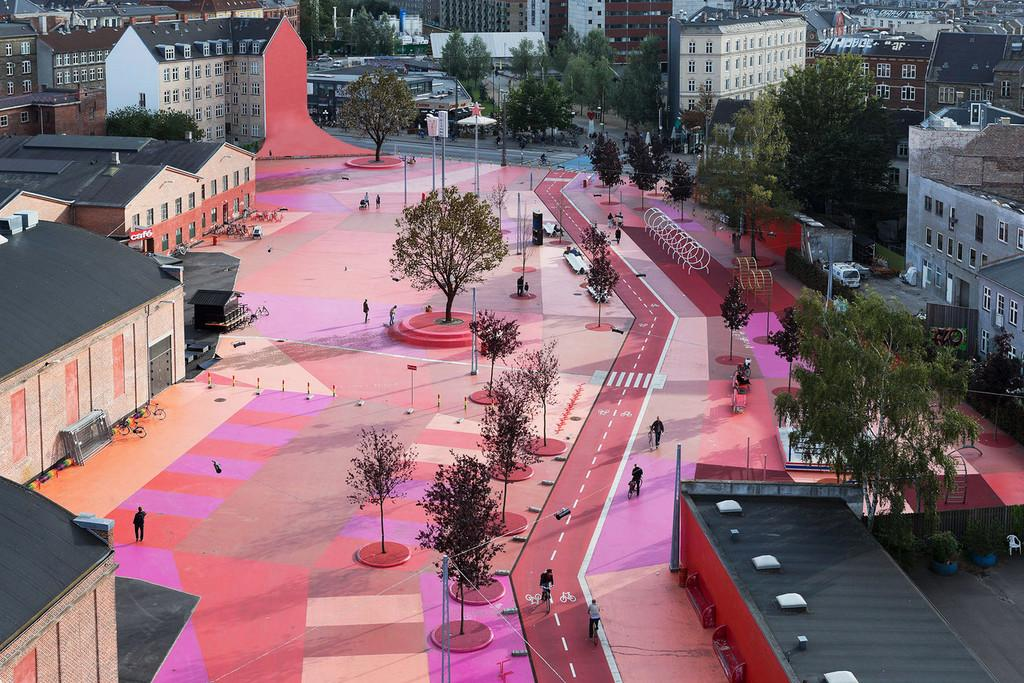What is the main feature in the middle of the image? There is a colorful path in the middle of the image. What can be seen alongside the path? Trees are present alongside the path. What are the people in the image doing? People are walking on the path. What type of structures are visible on either side of the path? There are buildings on either side of the path. What is the chance of rolling a six on the path in the image? There is no dice or rolling involved in the image; it features a colorful path with people walking on it. 